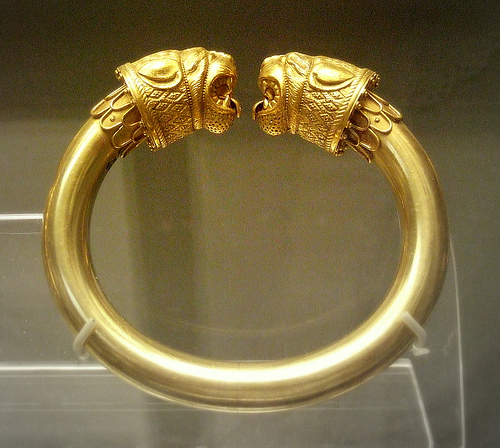<image>
Is there a tiger behind the tiger? No. The tiger is not behind the tiger. From this viewpoint, the tiger appears to be positioned elsewhere in the scene. 